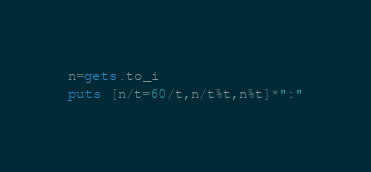Convert code to text. <code><loc_0><loc_0><loc_500><loc_500><_Ruby_>n=gets.to_i
puts [n/t=60/t,n/t%t,n%t]*":"</code> 